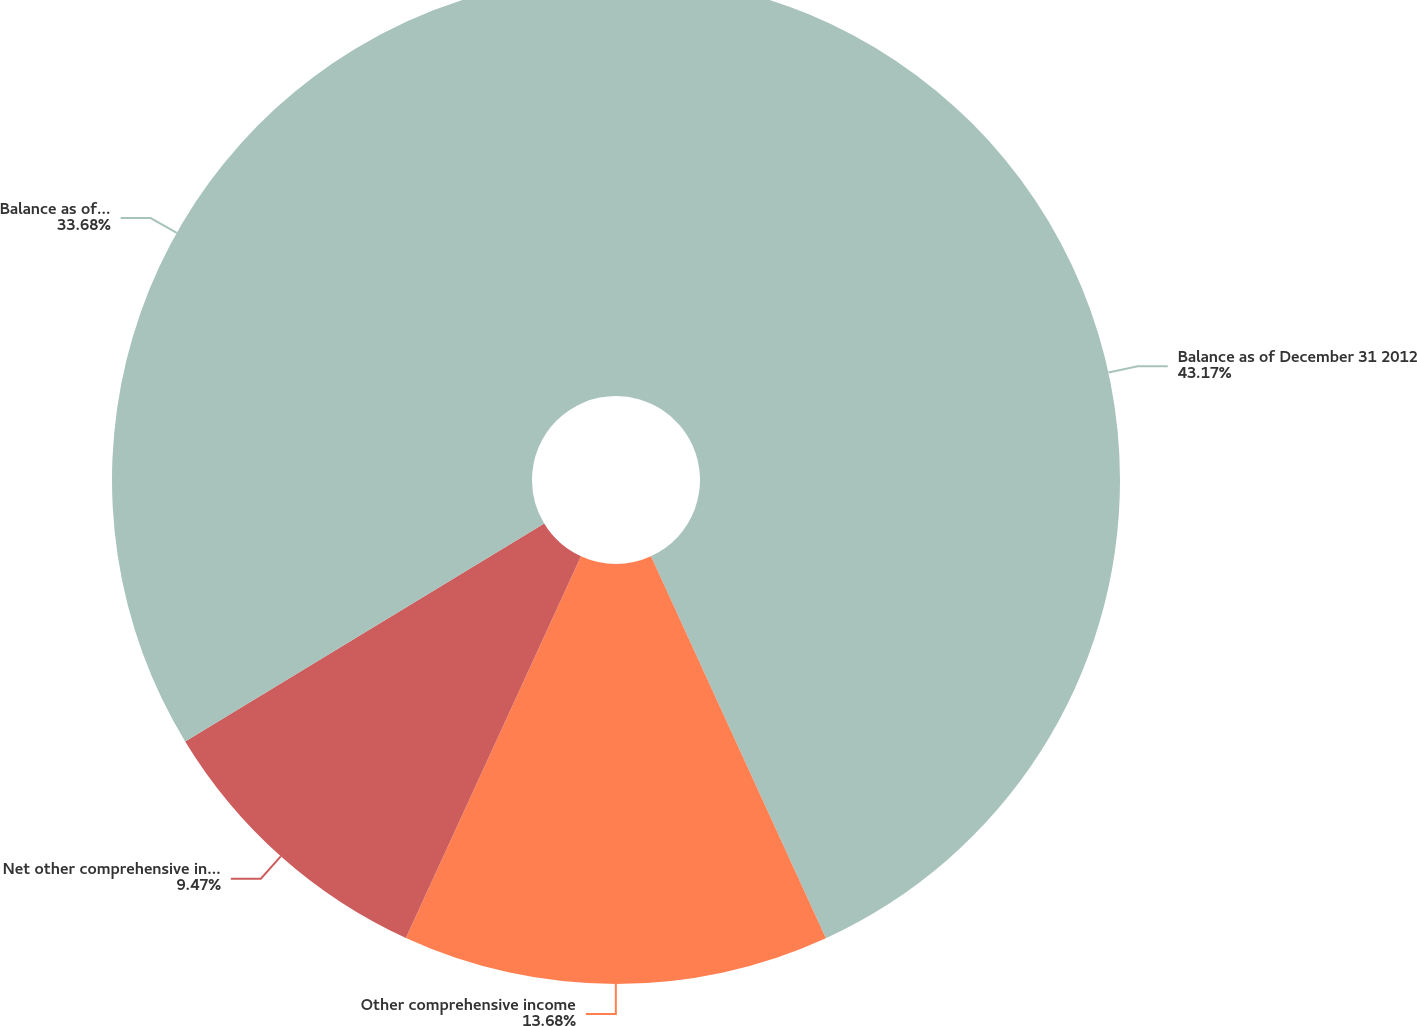<chart> <loc_0><loc_0><loc_500><loc_500><pie_chart><fcel>Balance as of December 31 2012<fcel>Other comprehensive income<fcel>Net other comprehensive income<fcel>Balance as of December 31 2013<nl><fcel>43.16%<fcel>13.68%<fcel>9.47%<fcel>33.68%<nl></chart> 